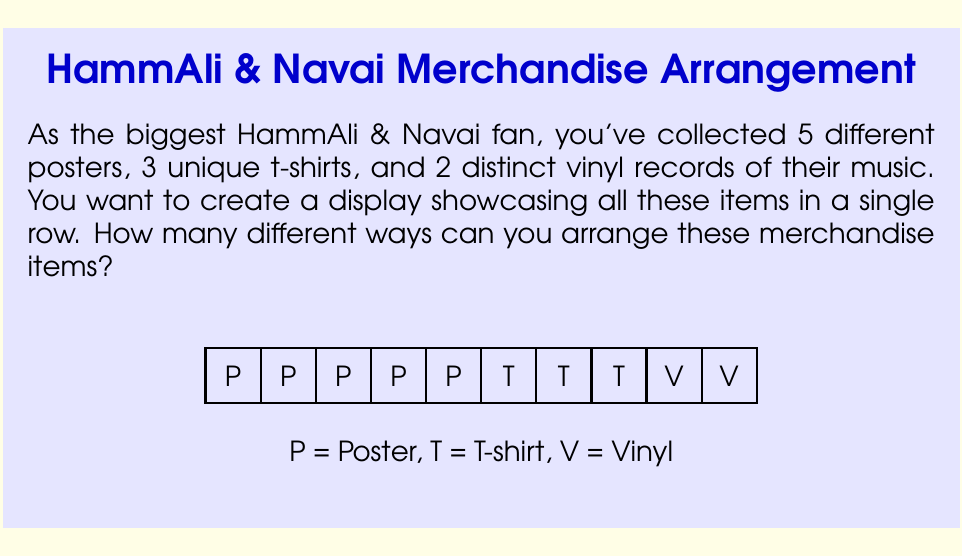What is the answer to this math problem? Let's approach this step-by-step:

1) First, we need to recognize that this is a permutation problem. We are arranging all the items in a row, and the order matters.

2) We have a total of 10 items:
   - 5 posters
   - 3 t-shirts
   - 2 vinyl records

3) If all items were different, we would have 10! ways to arrange them. However, we have repeated items (multiple posters and t-shirts), which we need to account for.

4) When we have repeated elements in a permutation, we divide by the factorial of the number of repetitions for each repeated element. This is because the arrangements of these identical items among themselves don't create a new overall arrangement.

5) The mathematical formula for this scenario is:

   $$\frac{10!}{5! \cdot 3! \cdot 2!}$$

6) Let's calculate this:
   $$\begin{align}
   &= \frac{10 \cdot 9 \cdot 8 \cdot 7 \cdot 6 \cdot 5!}{5! \cdot 3 \cdot 2 \cdot 1 \cdot 2 \cdot 1} \\
   &= \frac{10 \cdot 9 \cdot 8 \cdot 7 \cdot 6}{3 \cdot 2 \cdot 2} \\
   &= \frac{30240}{12} \\
   &= 2520
   \end{align}$$

Therefore, there are 2520 different ways to arrange the HammAli & Navai merchandise items in the display.
Answer: 2520 